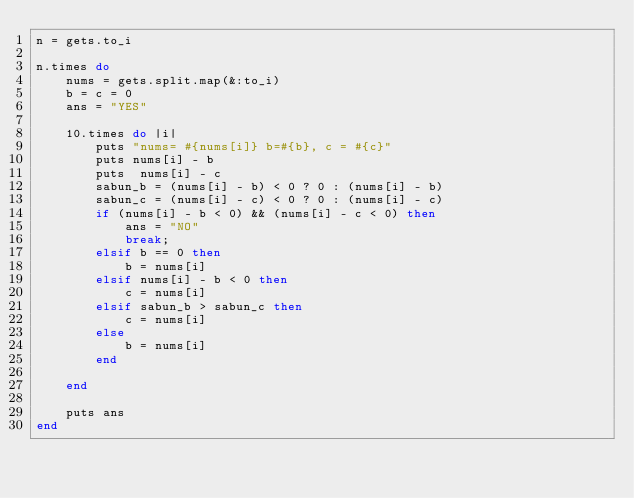<code> <loc_0><loc_0><loc_500><loc_500><_Ruby_>n = gets.to_i

n.times do
    nums = gets.split.map(&:to_i)
    b = c = 0
    ans = "YES"

    10.times do |i|
        puts "nums= #{nums[i]} b=#{b}, c = #{c}"
        puts nums[i] - b
        puts  nums[i] - c
        sabun_b = (nums[i] - b) < 0 ? 0 : (nums[i] - b)
        sabun_c = (nums[i] - c) < 0 ? 0 : (nums[i] - c)
        if (nums[i] - b < 0) && (nums[i] - c < 0) then
            ans = "NO"
            break;
        elsif b == 0 then
            b = nums[i]
        elsif nums[i] - b < 0 then
            c = nums[i]
        elsif sabun_b > sabun_c then
            c = nums[i]
        else
            b = nums[i]
        end
        
    end

    puts ans
end
</code> 